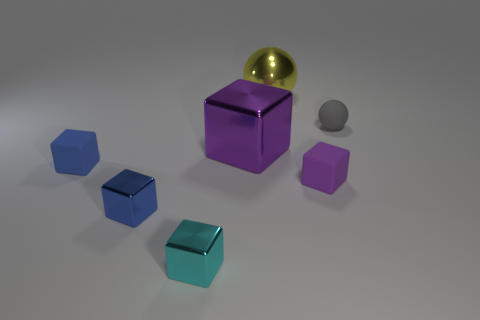Subtract all cyan cubes. Subtract all brown cylinders. How many cubes are left? 4 Add 1 small purple matte blocks. How many objects exist? 8 Subtract all cubes. How many objects are left? 2 Subtract 0 blue cylinders. How many objects are left? 7 Subtract all cyan rubber cylinders. Subtract all yellow metallic spheres. How many objects are left? 6 Add 5 tiny gray rubber balls. How many tiny gray rubber balls are left? 6 Add 2 purple metal cubes. How many purple metal cubes exist? 3 